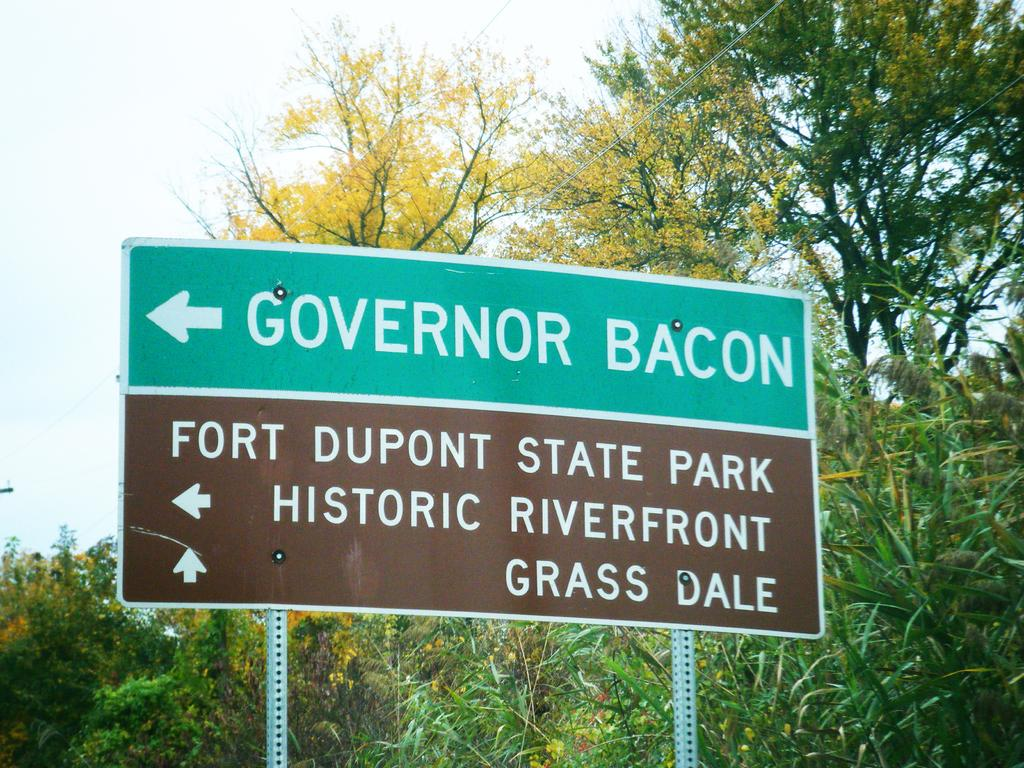What is located in the foreground of the image? There is a signboard in the foreground of the image. What can be seen in the background of the image? There are trees and cables visible in the background of the image. What part of the natural environment is visible in the image? The sky is visible in the background of the image. How many birds are gripping the yarn in the image? There are no birds or yarn present in the image. 